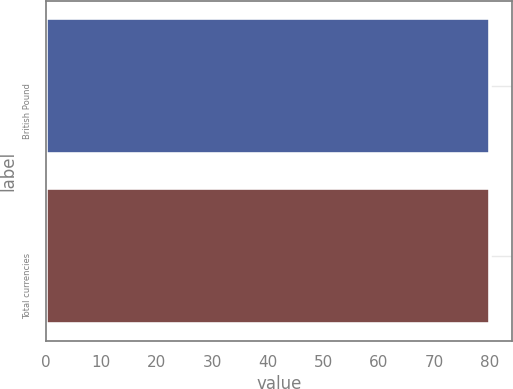<chart> <loc_0><loc_0><loc_500><loc_500><bar_chart><fcel>British Pound<fcel>Total currencies<nl><fcel>80<fcel>80.1<nl></chart> 